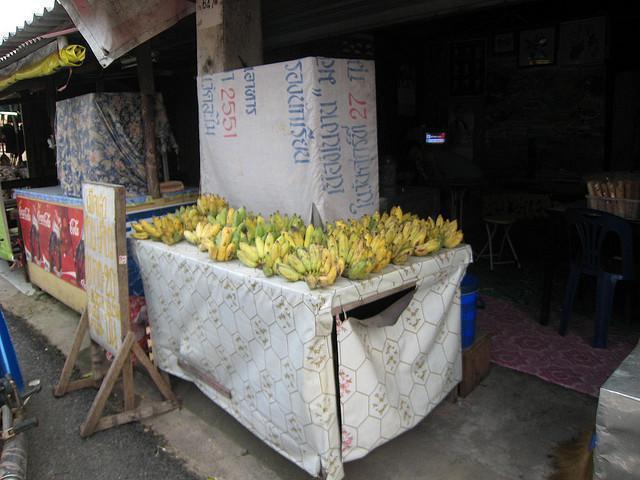What country produces a large number of these yellow food items?
Make your selection from the four choices given to correctly answer the question.
Options: Greenland, siberia, wessex, india. India. 